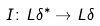Convert formula to latex. <formula><loc_0><loc_0><loc_500><loc_500>I \colon L \delta ^ { * } \to L \delta</formula> 